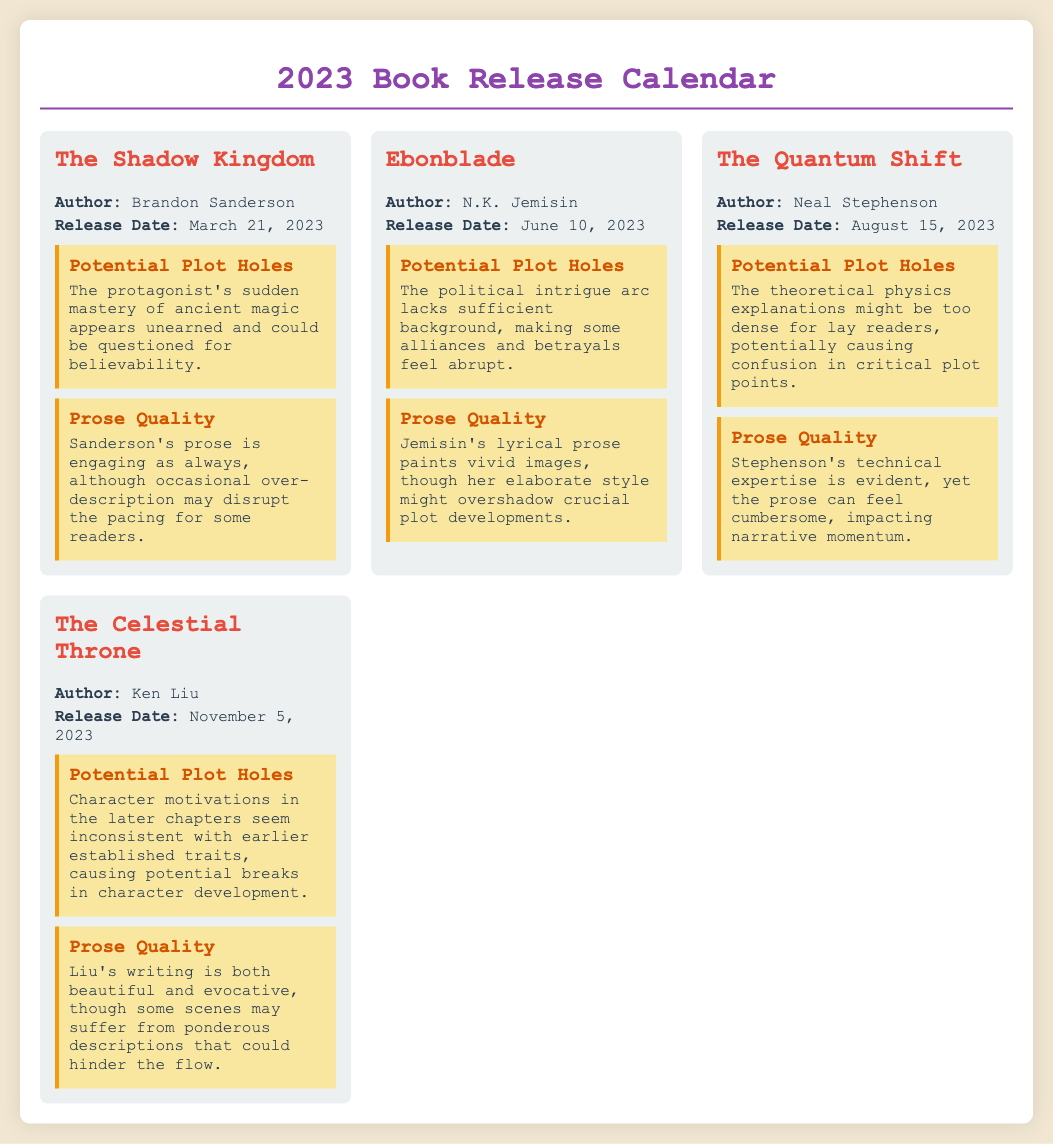What is the title of the book by Brandon Sanderson? The document lists "The Shadow Kingdom" as the title of Brandon Sanderson's book.
Answer: The Shadow Kingdom What is the release date of "Ebonblade"? The document states that "Ebonblade" is scheduled for release on June 10, 2023.
Answer: June 10, 2023 Who is the author of "The Quantum Shift"? The document identifies Neal Stephenson as the author of "The Quantum Shift."
Answer: Neal Stephenson What potential plot hole is mentioned for "The Celestial Throne"? The document suggests that character motivations in later chapters seem inconsistent with earlier established traits for "The Celestial Throne."
Answer: Inconsistent character motivations Which book's prose is described as both beautiful and evocative? The document states that Liu's writing in "The Celestial Throne" is described as both beautiful and evocative.
Answer: The Celestial Throne How many books are listed in the document? There are four books listed in the document.
Answer: Four 